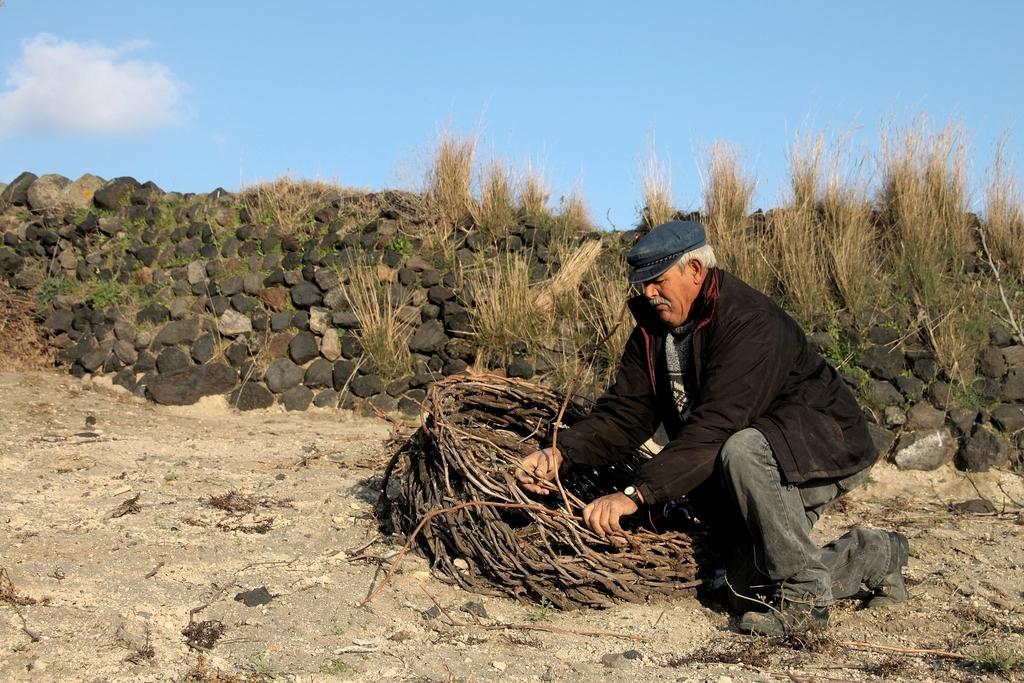Could you give a brief overview of what you see in this image? In this picture we can see a man in the black jacket is in squat position and behind the man there are stones, grass and a sky. 